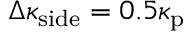<formula> <loc_0><loc_0><loc_500><loc_500>\Delta \kappa _ { s i d e } = 0 . 5 \kappa _ { p }</formula> 